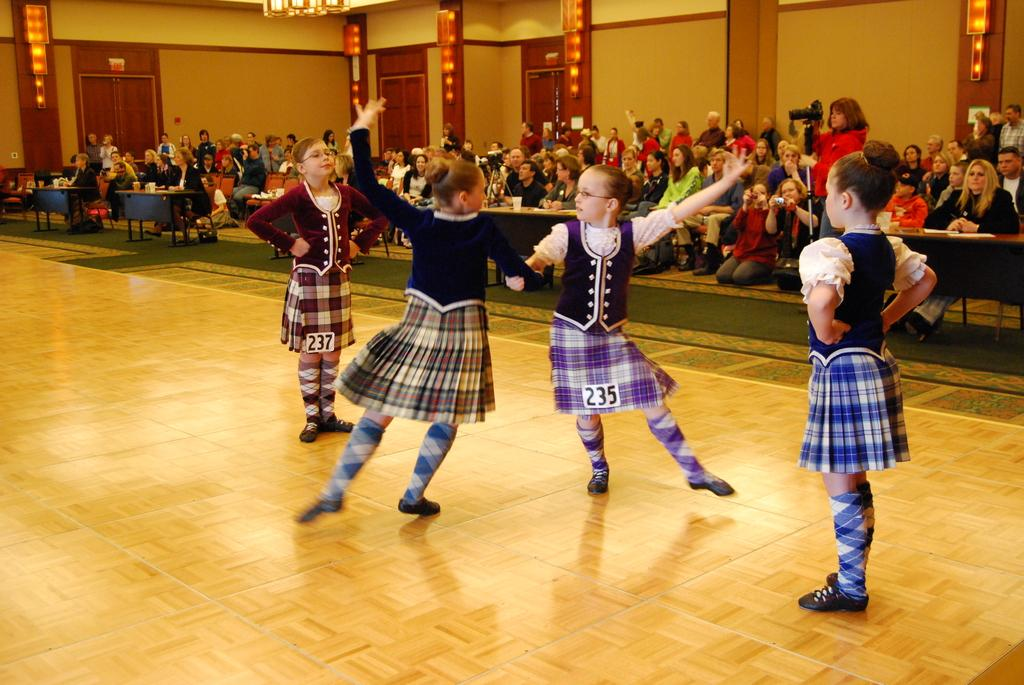What are the girls in the image doing? The girls in the image are dancing. Where are the girls dancing? The girls are dancing on the floor. What can be seen in the background of the image? In the background of the image, there are people, tables, a wall, doors, lights, and other objects. Are any people holding objects in the image? Yes, some people are holding objects in the image. What time of day is the creator of the image depicted in the image? The image does not depict the creator of the image, so it is not possible to determine the time of day they might be in. 